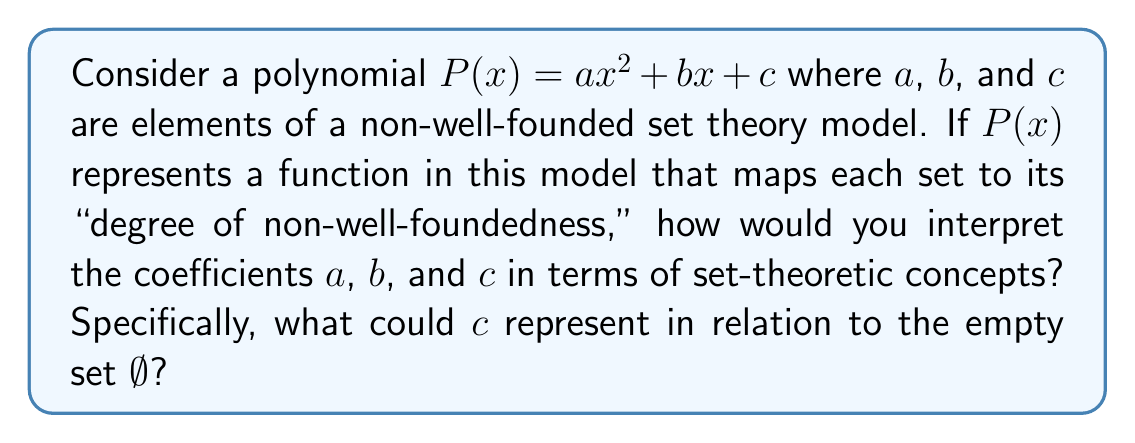Show me your answer to this math problem. This question requires us to think about polynomials in the context of non-well-founded set theory, which is relevant to anti-foundation axioms. Let's break down the interpretation:

1) In standard set theory, every set is well-founded, meaning there are no infinite descending chains of element-hood. However, in non-well-founded set theory, we allow such infinite chains.

2) The polynomial $P(x) = ax^2 + bx + c$ is being used to model the "degree of non-well-foundedness" of sets. This is a creative way to quantify how far a set deviates from being well-founded.

3) Interpreting the coefficients:

   a) $c$ (constant term): This represents the baseline "non-well-foundedness." Since it's not dependent on $x$, it should represent the degree for the simplest set, which is the empty set $\emptyset$.

   b) $b$ (linear term): This could represent the contribution to non-well-foundedness from direct elements of a set.

   c) $a$ (quadratic term): This might represent the contribution from "nested" non-well-foundedness, or second-order effects.

4) Focusing on $c$: In standard set theory, the empty set is well-founded. However, in some non-well-founded models, even $\emptyset$ can have non-trivial properties.

5) One interpretation of $c$ could be the "self-containment" of $\emptyset$. In some non-well-founded models, we might have $\emptyset = \{\emptyset\}$, which would give it a non-zero degree of non-well-foundedness.

6) The value of $c$ could thus represent the "looping" or "circularity" inherent in the model's conception of the empty set.

This interpretation aligns with research into logical paradoxes in set theory, as it provides a quantitative way to measure the degree to which sets in different models violate the traditional axiom of foundation.
Answer: $c$ could represent the degree of self-reference or circularity inherent in the empty set $\emptyset$ within the given non-well-founded set theory model. A non-zero value for $c$ would indicate that even the empty set has some degree of non-well-foundedness, possibly due to properties like $\emptyset = \{\emptyset\}$ in the model. 